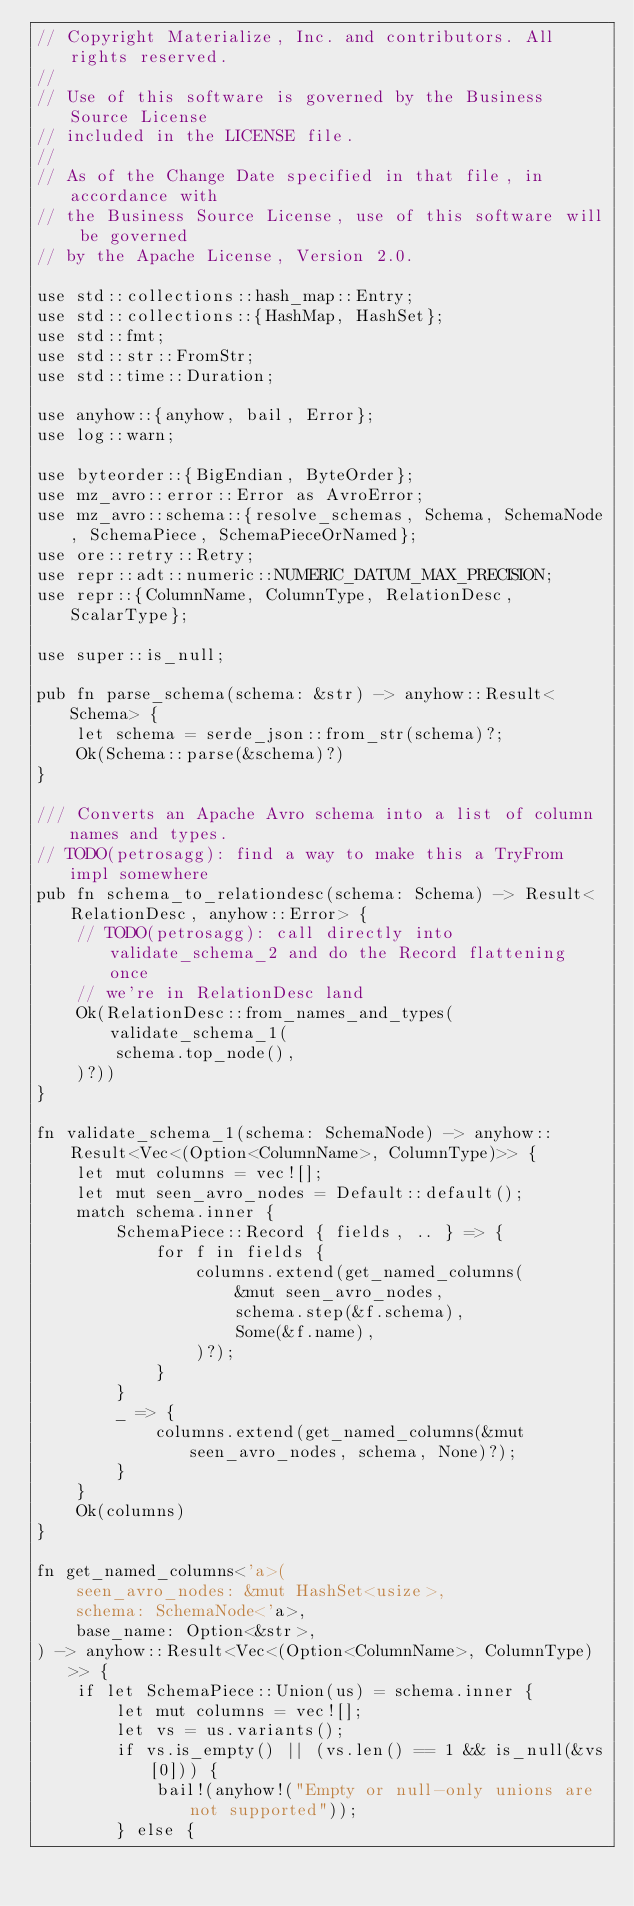<code> <loc_0><loc_0><loc_500><loc_500><_Rust_>// Copyright Materialize, Inc. and contributors. All rights reserved.
//
// Use of this software is governed by the Business Source License
// included in the LICENSE file.
//
// As of the Change Date specified in that file, in accordance with
// the Business Source License, use of this software will be governed
// by the Apache License, Version 2.0.

use std::collections::hash_map::Entry;
use std::collections::{HashMap, HashSet};
use std::fmt;
use std::str::FromStr;
use std::time::Duration;

use anyhow::{anyhow, bail, Error};
use log::warn;

use byteorder::{BigEndian, ByteOrder};
use mz_avro::error::Error as AvroError;
use mz_avro::schema::{resolve_schemas, Schema, SchemaNode, SchemaPiece, SchemaPieceOrNamed};
use ore::retry::Retry;
use repr::adt::numeric::NUMERIC_DATUM_MAX_PRECISION;
use repr::{ColumnName, ColumnType, RelationDesc, ScalarType};

use super::is_null;

pub fn parse_schema(schema: &str) -> anyhow::Result<Schema> {
    let schema = serde_json::from_str(schema)?;
    Ok(Schema::parse(&schema)?)
}

/// Converts an Apache Avro schema into a list of column names and types.
// TODO(petrosagg): find a way to make this a TryFrom impl somewhere
pub fn schema_to_relationdesc(schema: Schema) -> Result<RelationDesc, anyhow::Error> {
    // TODO(petrosagg): call directly into validate_schema_2 and do the Record flattening once
    // we're in RelationDesc land
    Ok(RelationDesc::from_names_and_types(validate_schema_1(
        schema.top_node(),
    )?))
}

fn validate_schema_1(schema: SchemaNode) -> anyhow::Result<Vec<(Option<ColumnName>, ColumnType)>> {
    let mut columns = vec![];
    let mut seen_avro_nodes = Default::default();
    match schema.inner {
        SchemaPiece::Record { fields, .. } => {
            for f in fields {
                columns.extend(get_named_columns(
                    &mut seen_avro_nodes,
                    schema.step(&f.schema),
                    Some(&f.name),
                )?);
            }
        }
        _ => {
            columns.extend(get_named_columns(&mut seen_avro_nodes, schema, None)?);
        }
    }
    Ok(columns)
}

fn get_named_columns<'a>(
    seen_avro_nodes: &mut HashSet<usize>,
    schema: SchemaNode<'a>,
    base_name: Option<&str>,
) -> anyhow::Result<Vec<(Option<ColumnName>, ColumnType)>> {
    if let SchemaPiece::Union(us) = schema.inner {
        let mut columns = vec![];
        let vs = us.variants();
        if vs.is_empty() || (vs.len() == 1 && is_null(&vs[0])) {
            bail!(anyhow!("Empty or null-only unions are not supported"));
        } else {</code> 